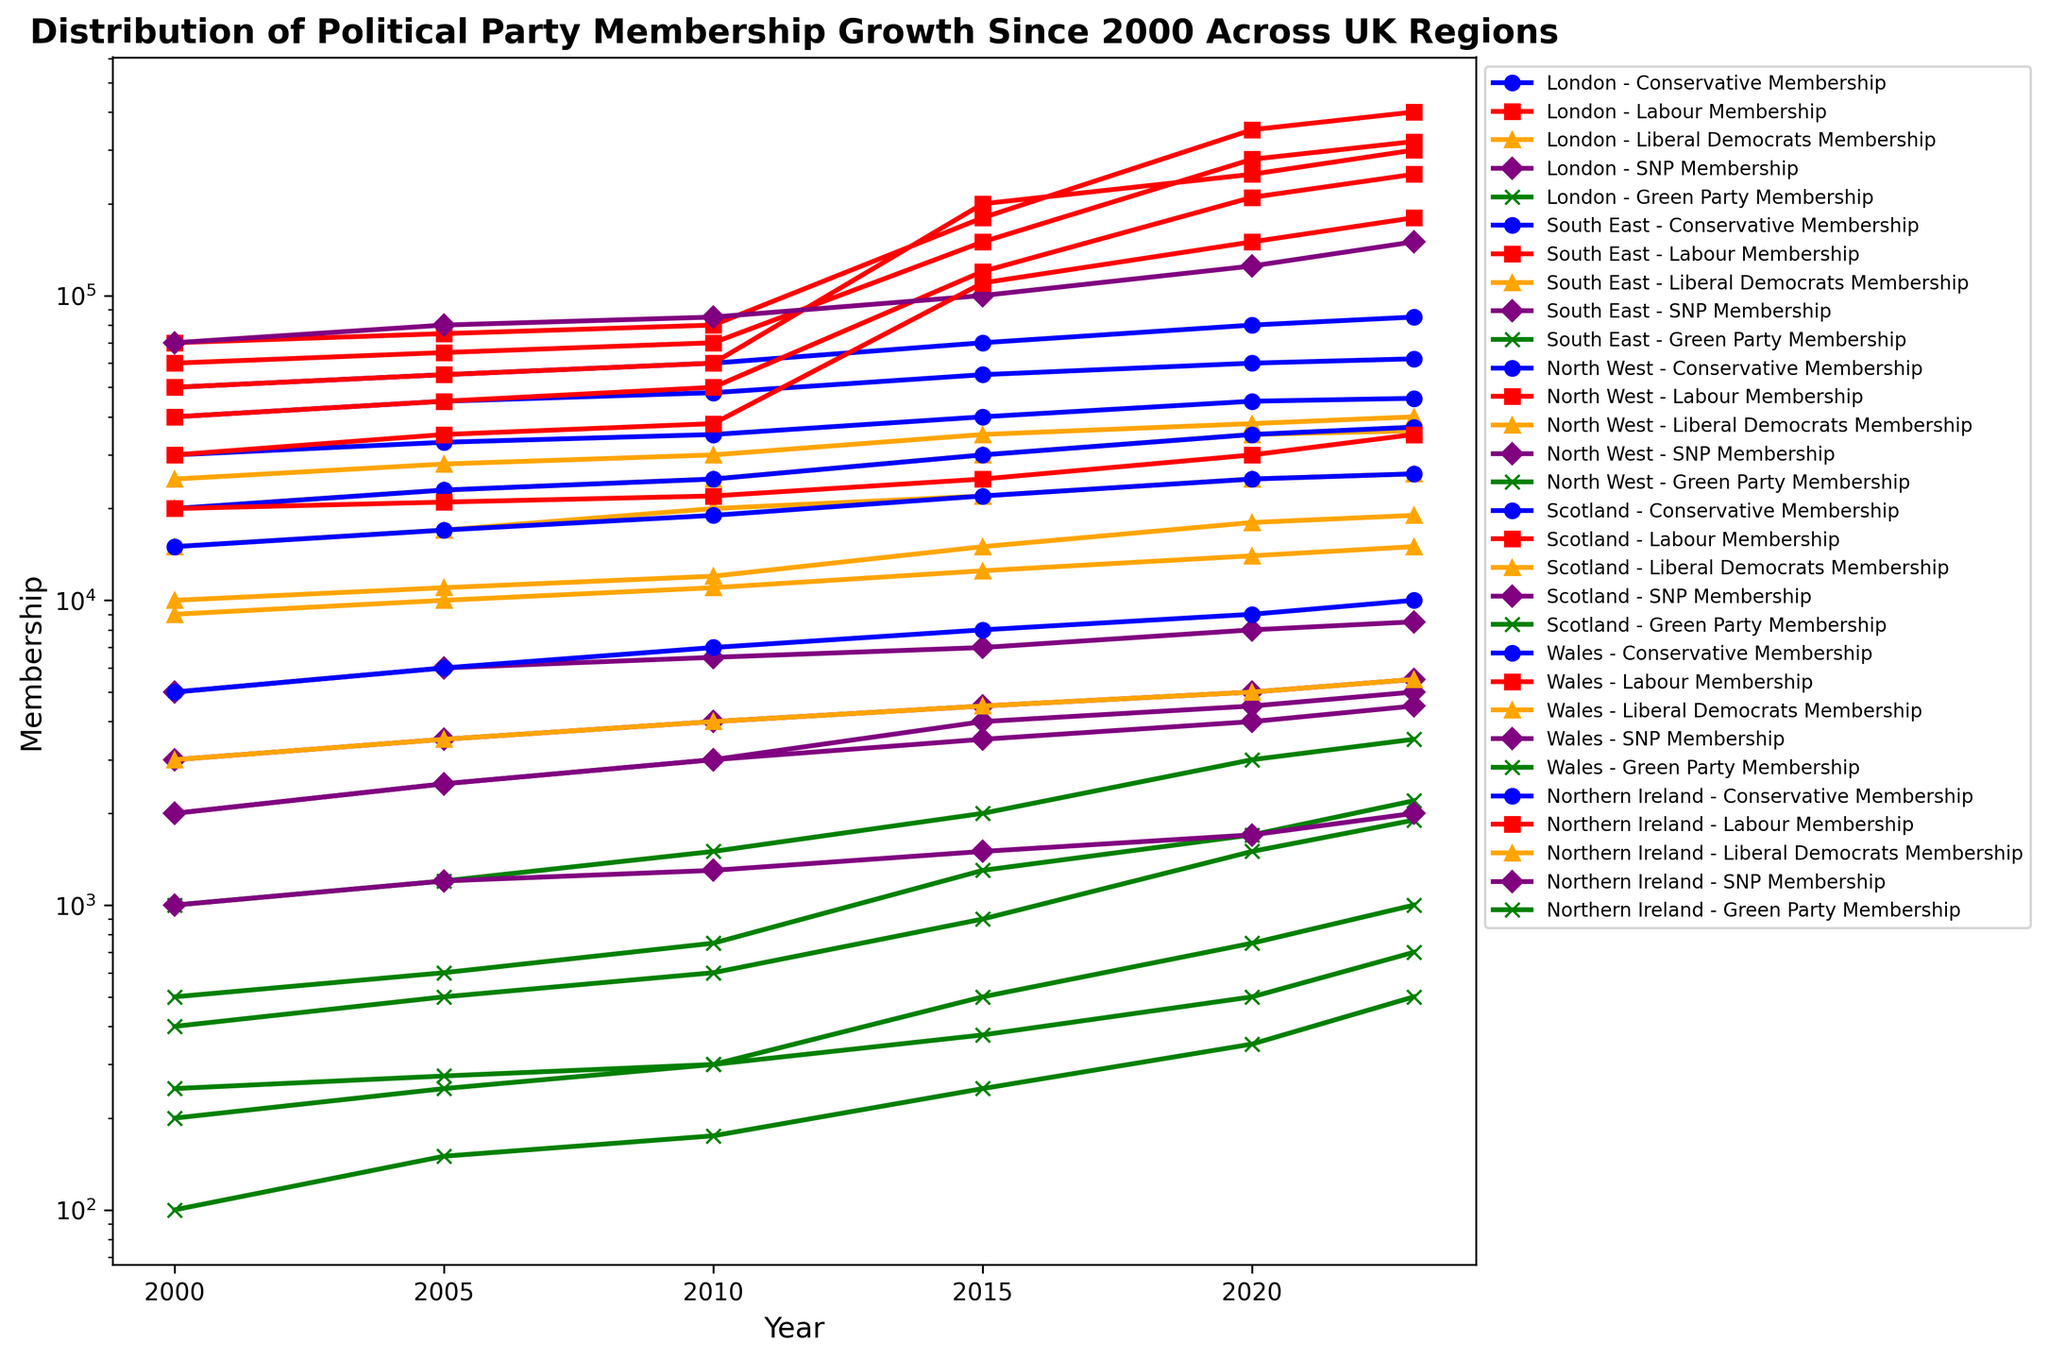Which region has the highest Labour membership in 2023? Look for the Labour membership values in 2023 by identifying the red-marked data points and compare them across all regions to find the highest value.
Answer: London What is the difference in Conservative membership between London and the South East in 2023? Identify the Conservative membership values for London and South East in 2023 by observing the blue-marked data points. Subtract the value for the South East from the value for London.
Answer: 23000 By how much did the Green Party membership in Wales increase from 2000 to 2023? Locate the Green Party membership values in Wales for the years 2000 and 2023. Observe the green-marked data points for Wales and subtract the value for 2000 from the value for 2023.
Answer: 800 Which political party has the steepest growth in membership in Scotland from 2000 to 2023? Observe the slope of the lines corresponding to each party in Scotland from 2000 to 2023. Identify the purple-marked line for SNP, which shows the steepest upward trajectory.
Answer: SNP Compare the rate of membership growth for the Labour Party between North West and Northern Ireland from 2000 to 2023. Which region has a faster growth rate? By examining the red-marked data points, note the increase in Labour membership in North West and Northern Ireland from 2000 to 2023. Compare the slopes of the respective lines to determine that North West has a steeper slope, indicating a faster growth rate.
Answer: North West What's the average Labour Party membership in Scotland across the years plotted (2000, 2005, 2010, 2015, 2020, 2023)? Identify the Labour membership values for each plotted year in Scotland from the red-marked data points. Calculate the average by adding these values and dividing by the number of years: (40000 + 45000 + 50000 + 120000 + 210000 + 250000) / 6.
Answer: 118333.33 In which region did the Liberal Democrats membership reach its peak, and what year did that occur? Look for the highest point among all orange-marked lines across all regions. Note that the South East had the highest value at 40000 in 2023.
Answer: South East, 2023 Among all regions, which one shows the slowest growth in Conservative membership from 2000 to 2023? Compare the slopes of the blue-marked lines for Conservative membership across all regions to find the flattest slope, indicating slowest growth rate.
Answer: Northern Ireland What is the total SNP membership in 2020 across all regions? Locate the SNP membership values for the year 2020 in all regions by observing the purple-marked data points and sum them up: 8000 (London) + 5000 (South East) + 4000 (North West) + 125000 (Scotland) + 4500 (Wales) + 1700 (Northern Ireland).
Answer: 148200 Which region has the largest disparity between Conservative and Labour memberships in 2023? For each region in 2023, look at the difference between the Conservative membership (blue-marked) and Labour membership (red-marked) values. The largest disparity is found in London (400000 - 85000).
Answer: London 